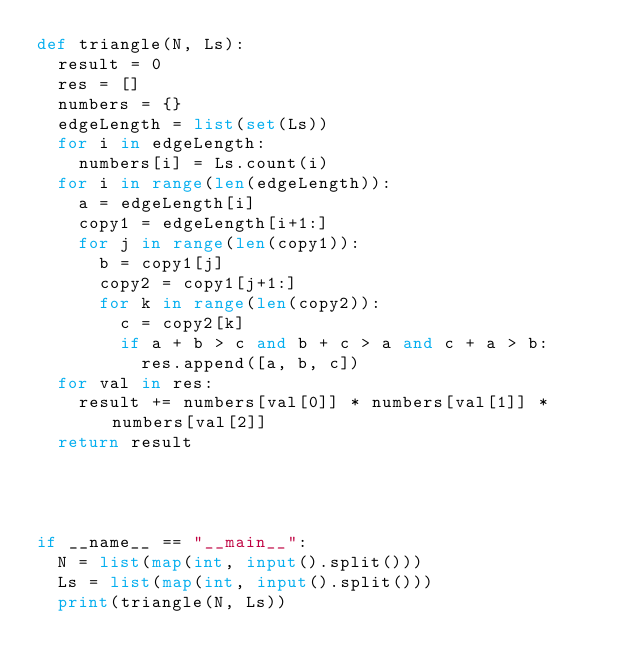<code> <loc_0><loc_0><loc_500><loc_500><_Python_>def triangle(N, Ls):
  result = 0
  res = []
  numbers = {}
  edgeLength = list(set(Ls))
  for i in edgeLength:
    numbers[i] = Ls.count(i)
  for i in range(len(edgeLength)):
    a = edgeLength[i]   
    copy1 = edgeLength[i+1:]
    for j in range(len(copy1)):
      b = copy1[j]
      copy2 = copy1[j+1:]
      for k in range(len(copy2)):
        c = copy2[k]
        if a + b > c and b + c > a and c + a > b:
          res.append([a, b, c])
  for val in res:
    result += numbers[val[0]] * numbers[val[1]] * numbers[val[2]]
  return result




if __name__ == "__main__":
  N = list(map(int, input().split()))
  Ls = list(map(int, input().split()))
  print(triangle(N, Ls))
</code> 